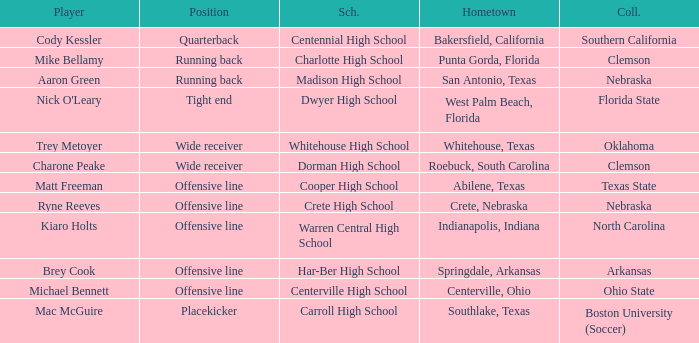What college did the placekicker go to? Boston University (Soccer). 